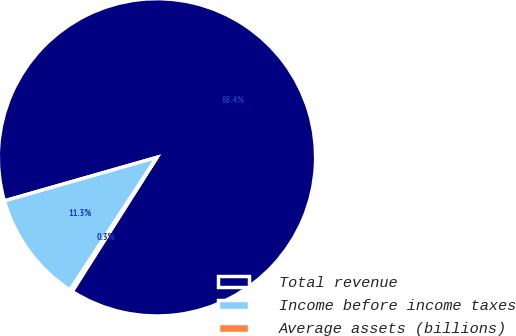Convert chart. <chart><loc_0><loc_0><loc_500><loc_500><pie_chart><fcel>Total revenue<fcel>Income before income taxes<fcel>Average assets (billions)<nl><fcel>88.4%<fcel>11.34%<fcel>0.26%<nl></chart> 